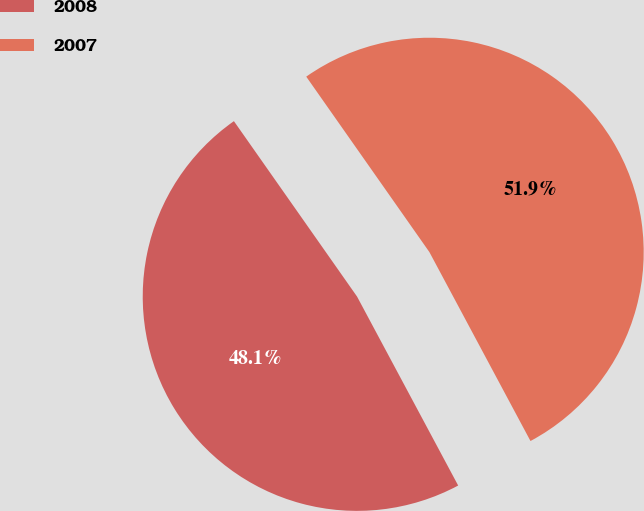Convert chart to OTSL. <chart><loc_0><loc_0><loc_500><loc_500><pie_chart><fcel>2008<fcel>2007<nl><fcel>48.08%<fcel>51.92%<nl></chart> 